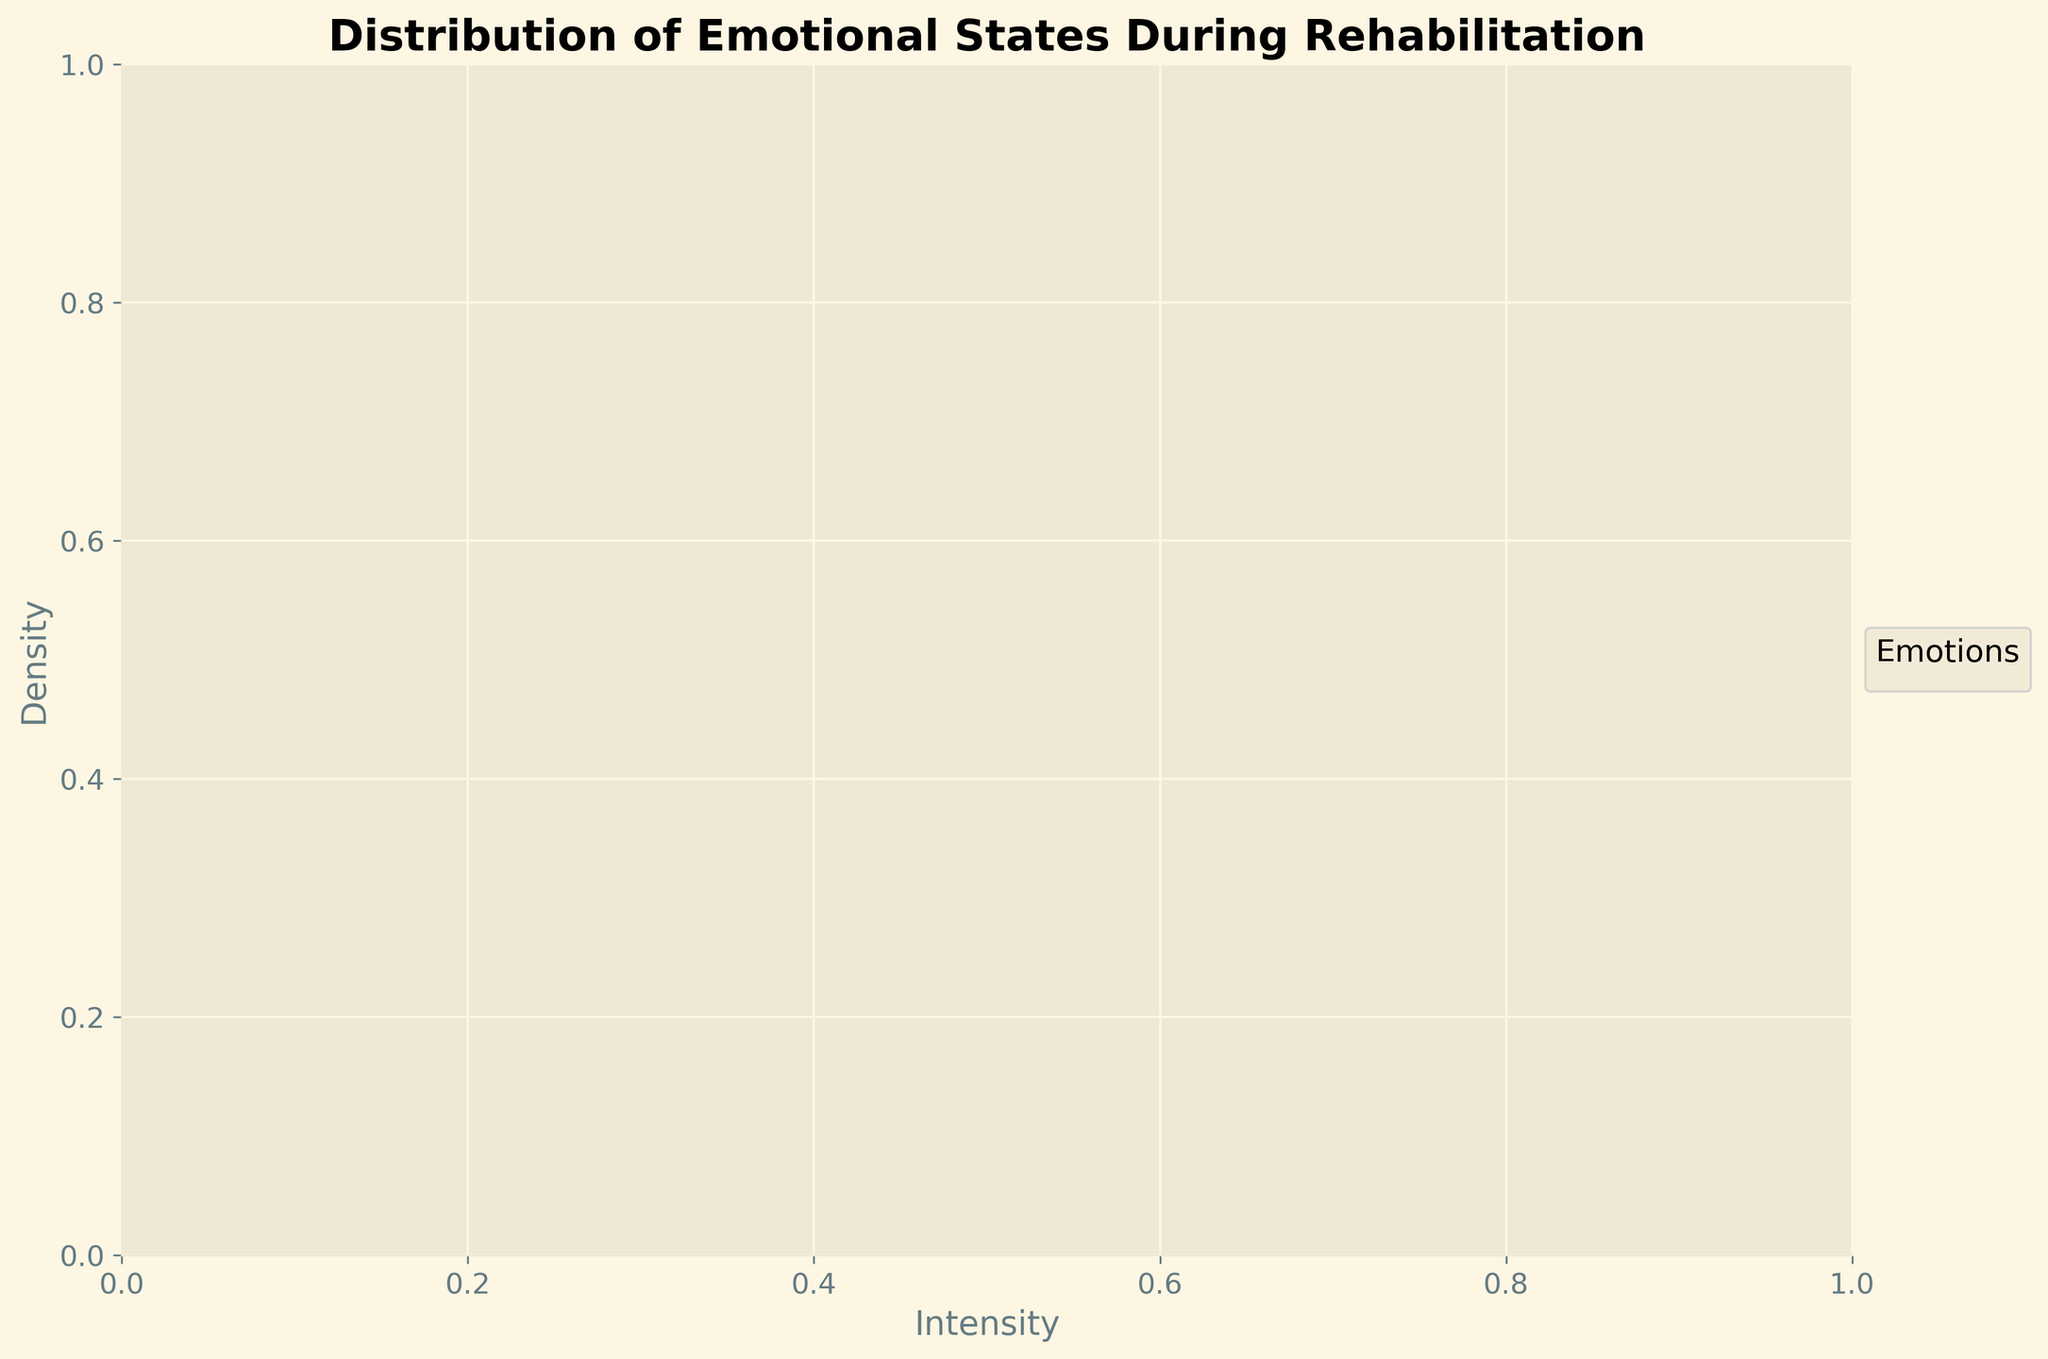What is the title of the figure? The title of the figure can be identified at the top part of the plot. It's usually written in bold text as a descriptor of the plot.
Answer: Distribution of Emotional States During Rehabilitation What are the x-axis and y-axis labels? The x-axis and y-axis labels describe what each axis represents in the plot. The x-axis label is "Intensity" and the y-axis label is "Density".
Answer: Intensity and Density Which emotion has the highest density at an intensity of 0.9? To find the highest density at an intensity of 0.9, we look at where the plotted lines peak at this intensity level. The highest peak at 0.9 is for the emotions recorded with an intensity of 0.9, such as 'Love', 'Peacefulness', 'Joy', and 'Gratitude'.
Answer: Love, Peacefulness, Joy, Gratitude How many different emotions are represented in the density plot? We count the different lines or curves, each representing a unique emotion on the plot. By legend or the visual inspection, each hue represents a different emotion.
Answer: 19 Which emotion has a peak density close to an intensity of 0.8? To find the emotion with peak density close to an intensity of 0.8, we observe the highest points of the curves around this intensity. Emotions like 'Motivation', 'Hope', 'Stress', 'Calm', and 'Anxiety' peak around this level.
Answer: Motivation, Hope, Stress, Calm, Anxiety What emotions have an intensity-related density peak between 0.5 and 0.6? Look at the curves which peak in the range of intensities 0.5 to 0.6. This range could cover peaks for emotions like 'Sadness' and 'Confusion'.
Answer: Sadness, Confusion Which two emotions have the most similar density distributions? Compare the shapes of the density curves to see which two are most overlapping or resemble each other in their spread and peak. Detailed visual comparison suggests that 'Anxiety' and 'Stress' might have closely resembling distributions.
Answer: Anxiety and Stress At which intensity level do we see a high density for the emotion 'Love'? Locate the 'Love' curve and find the highest point, indicating the peak of density. This peak is at or near an intensity level of 0.9.
Answer: 0.9 Is there any emotion that does not peak above an intensity of 0.9? Check each of the curves to see if all of them have a part where density is high, particularly looking for those that don't reach intensity 0.9. For example, 'Sadness' peaks below this intensity level.
Answer: Sadness Which emotions have relatively low density peaks compared to others? By observing the density plot, the curves that do not rise as high are those with relatively low density peaks. Emotions like 'Anger', 'Sadness', and 'Apathy' are less prominent compared to others like 'Love' and 'Peacefulness'.
Answer: Anger, Sadness, Apathy 